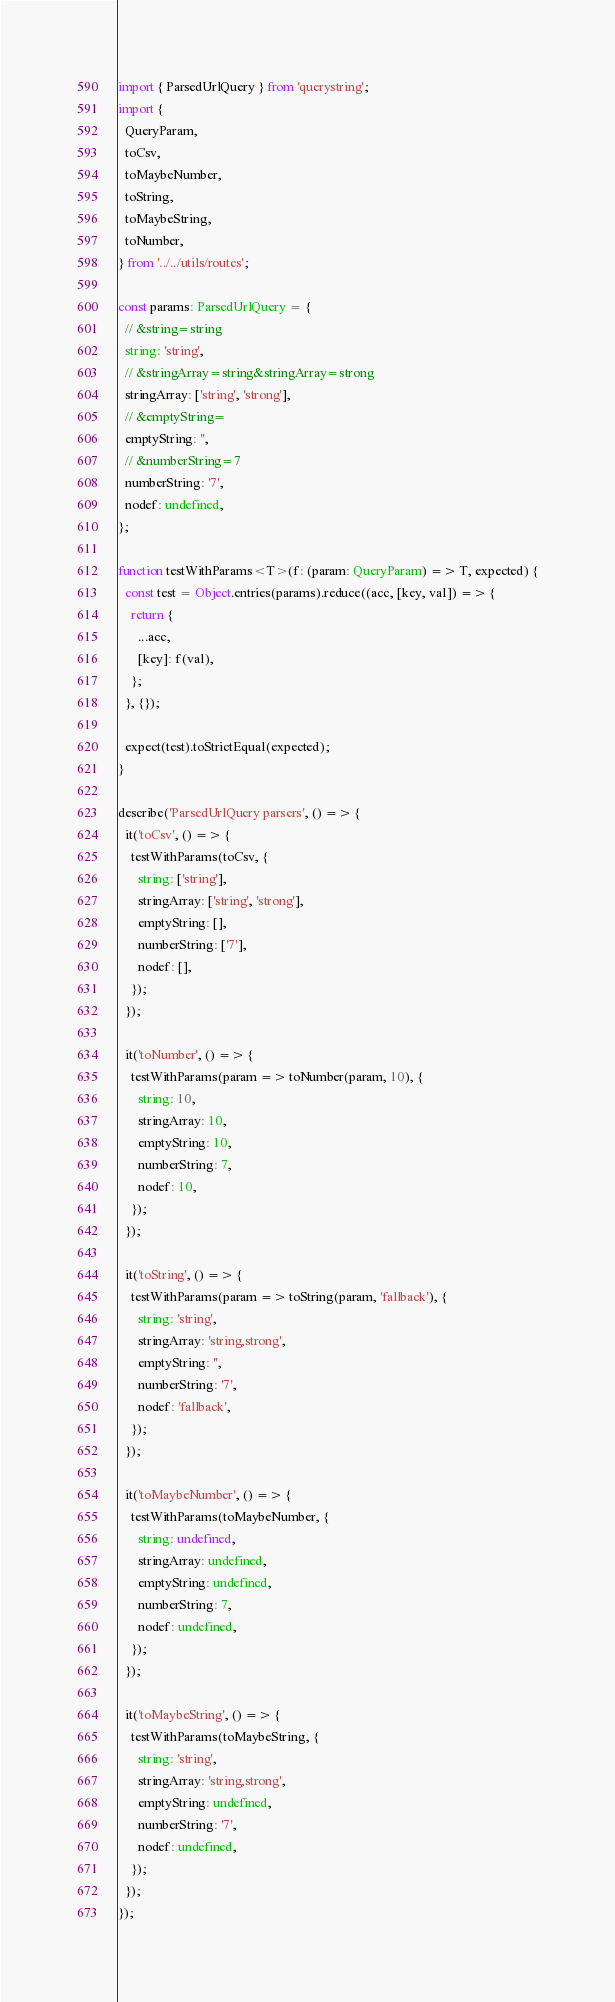Convert code to text. <code><loc_0><loc_0><loc_500><loc_500><_TypeScript_>import { ParsedUrlQuery } from 'querystring';
import {
  QueryParam,
  toCsv,
  toMaybeNumber,
  toString,
  toMaybeString,
  toNumber,
} from '../../utils/routes';

const params: ParsedUrlQuery = {
  // &string=string
  string: 'string',
  // &stringArray=string&stringArray=strong
  stringArray: ['string', 'strong'],
  // &emptyString=
  emptyString: '',
  // &numberString=7
  numberString: '7',
  nodef: undefined,
};

function testWithParams<T>(f: (param: QueryParam) => T, expected) {
  const test = Object.entries(params).reduce((acc, [key, val]) => {
    return {
      ...acc,
      [key]: f(val),
    };
  }, {});

  expect(test).toStrictEqual(expected);
}

describe('ParsedUrlQuery parsers', () => {
  it('toCsv', () => {
    testWithParams(toCsv, {
      string: ['string'],
      stringArray: ['string', 'strong'],
      emptyString: [],
      numberString: ['7'],
      nodef: [],
    });
  });

  it('toNumber', () => {
    testWithParams(param => toNumber(param, 10), {
      string: 10,
      stringArray: 10,
      emptyString: 10,
      numberString: 7,
      nodef: 10,
    });
  });

  it('toString', () => {
    testWithParams(param => toString(param, 'fallback'), {
      string: 'string',
      stringArray: 'string,strong',
      emptyString: '',
      numberString: '7',
      nodef: 'fallback',
    });
  });

  it('toMaybeNumber', () => {
    testWithParams(toMaybeNumber, {
      string: undefined,
      stringArray: undefined,
      emptyString: undefined,
      numberString: 7,
      nodef: undefined,
    });
  });

  it('toMaybeString', () => {
    testWithParams(toMaybeString, {
      string: 'string',
      stringArray: 'string,strong',
      emptyString: undefined,
      numberString: '7',
      nodef: undefined,
    });
  });
});
</code> 